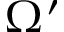<formula> <loc_0><loc_0><loc_500><loc_500>\Omega ^ { \prime }</formula> 